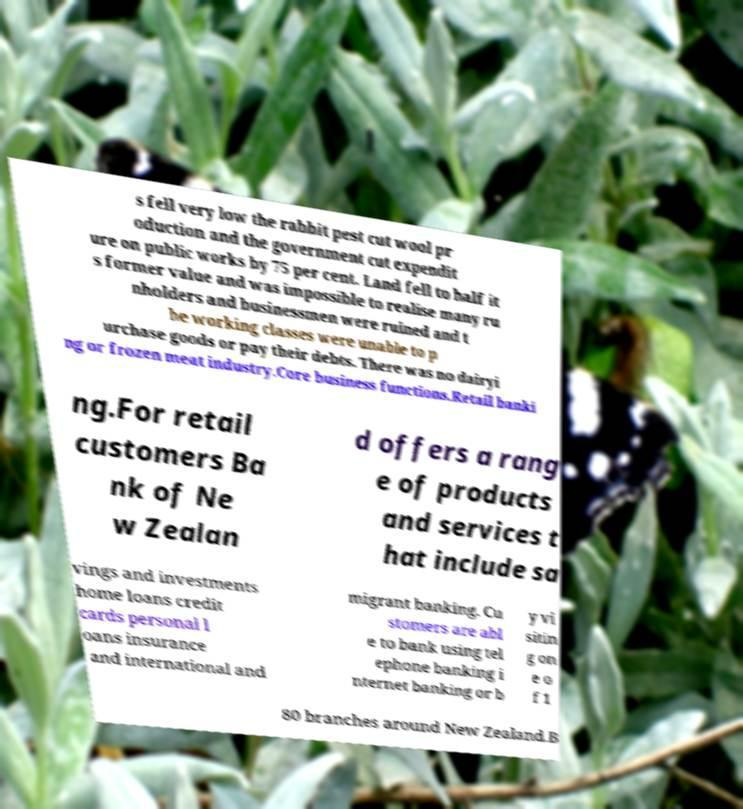Can you read and provide the text displayed in the image?This photo seems to have some interesting text. Can you extract and type it out for me? s fell very low the rabbit pest cut wool pr oduction and the government cut expendit ure on public works by 75 per cent. Land fell to half it s former value and was impossible to realise many ru nholders and businessmen were ruined and t he working classes were unable to p urchase goods or pay their debts. There was no dairyi ng or frozen meat industry.Core business functions.Retail banki ng.For retail customers Ba nk of Ne w Zealan d offers a rang e of products and services t hat include sa vings and investments home loans credit cards personal l oans insurance and international and migrant banking. Cu stomers are abl e to bank using tel ephone banking i nternet banking or b y vi sitin g on e o f 1 80 branches around New Zealand.B 